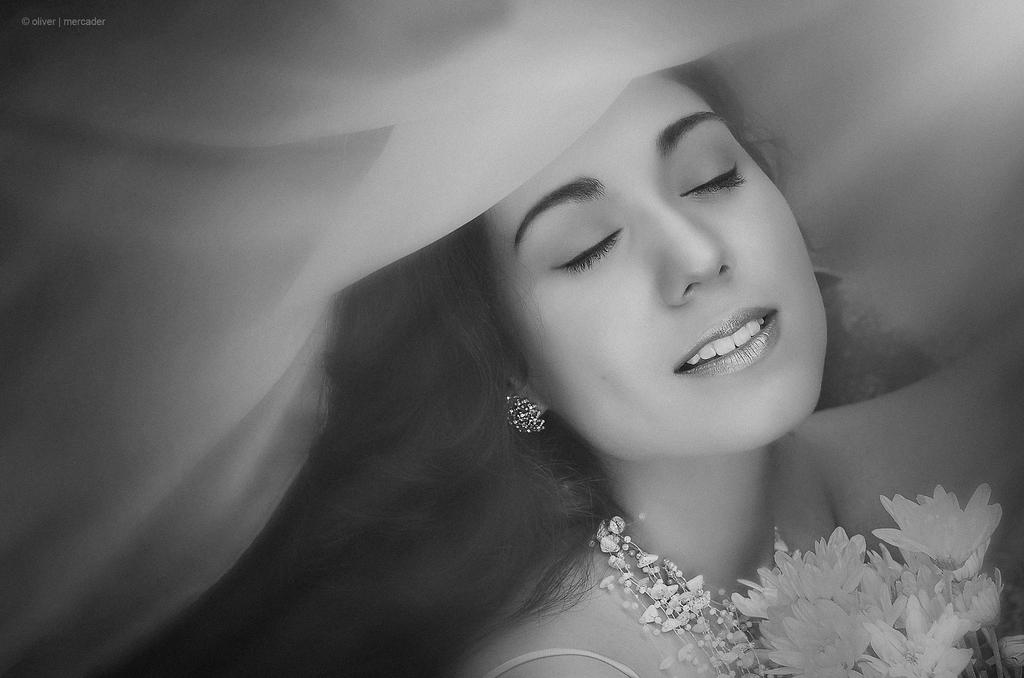Who is present in the image? There is a woman in the image. What is the woman wearing? The woman is wearing clothes and earrings. What is the woman's facial expression? The woman is smiling. Can you describe any additional items in the image? There is a flower bookmark in the image. Is there any indication of the image's origin or authenticity? Yes, there is a watermark in the image. What type of sea creature can be seen swimming near the woman in the image? There is no sea creature present in the image; it features a woman and a flower bookmark. What substance is the woman holding in her hand in the image? There is no substance visible in the woman's hand in the image. 